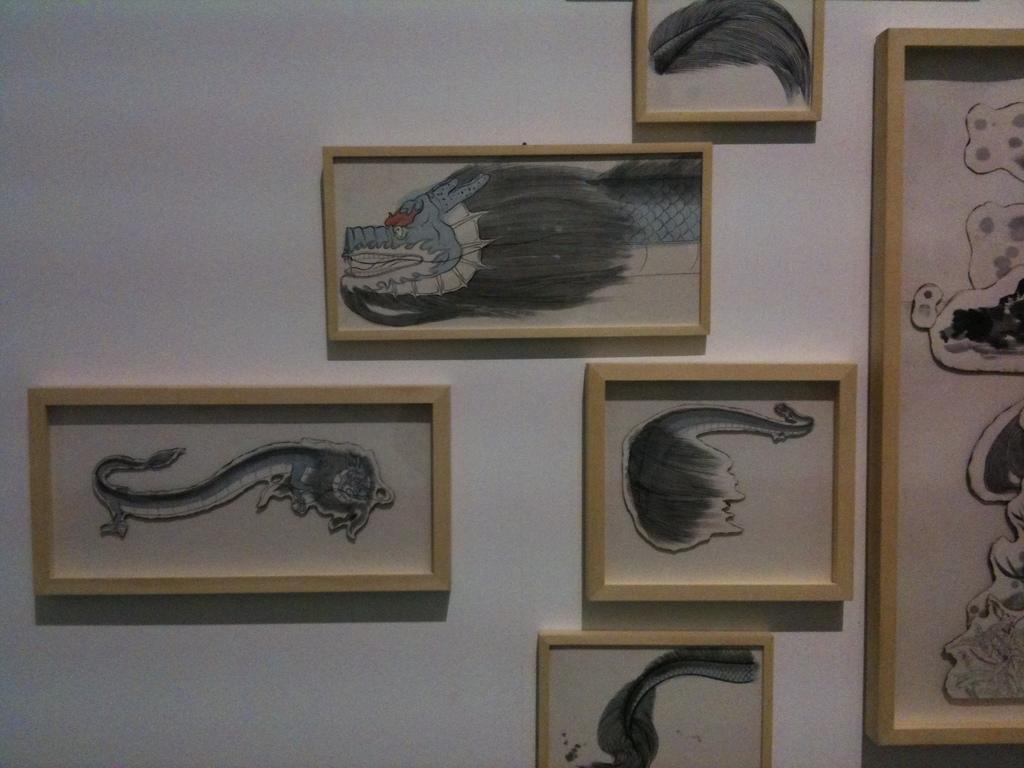How would you summarize this image in a sentence or two? These are the photo frames, which are attached to the wall. I think these are the paintings. This wall is white in color. 